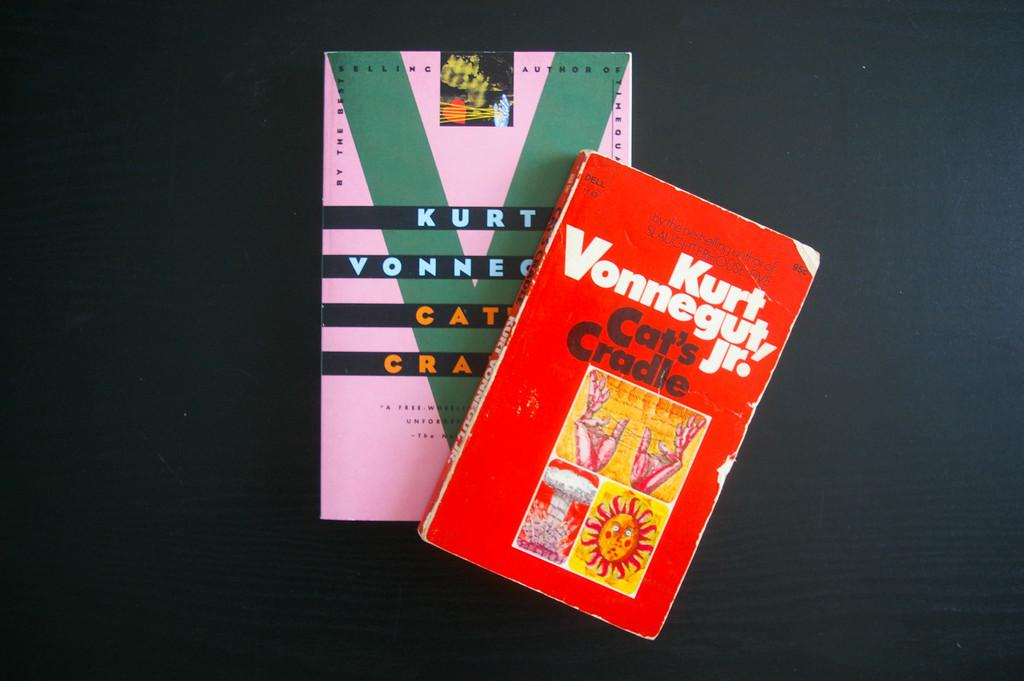<image>
Create a compact narrative representing the image presented. Two books written by Kurt Vonnegut Jr. sitting on a black table. 